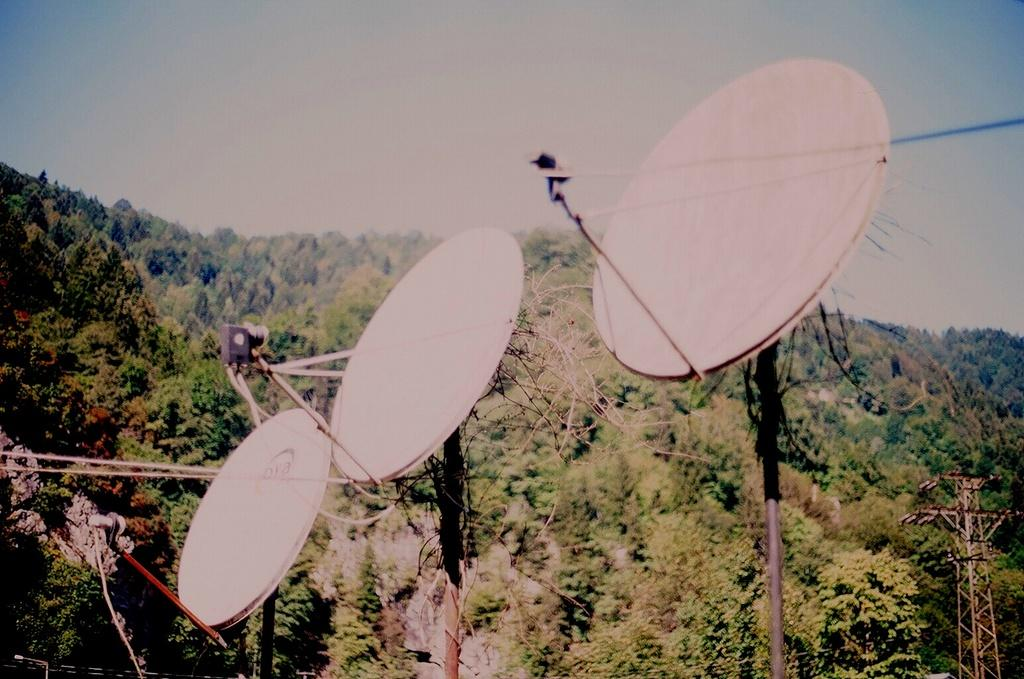What type of equipment can be seen in the image? There are dish antennas in the image. What else is present in the image besides the dish antennas? There are wires and towers in the image. What type of natural vegetation is visible in the image? There are trees in the image. What is the color of the sky in the image? The sky is blue in color. What type of song is being played by the pest in the image? There is no pest or song present in the image. What country is depicted in the image? The image does not depict a specific country; it shows dish antennas, wires, towers, trees, and a blue sky. 